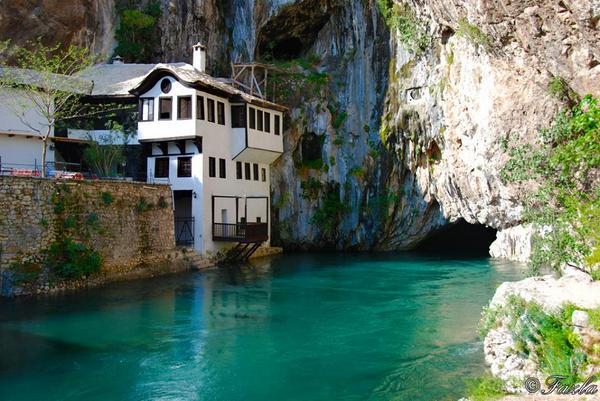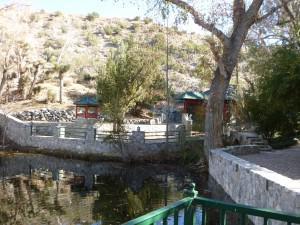The first image is the image on the left, the second image is the image on the right. Assess this claim about the two images: "There is a body of water on the images.". Correct or not? Answer yes or no. Yes. 